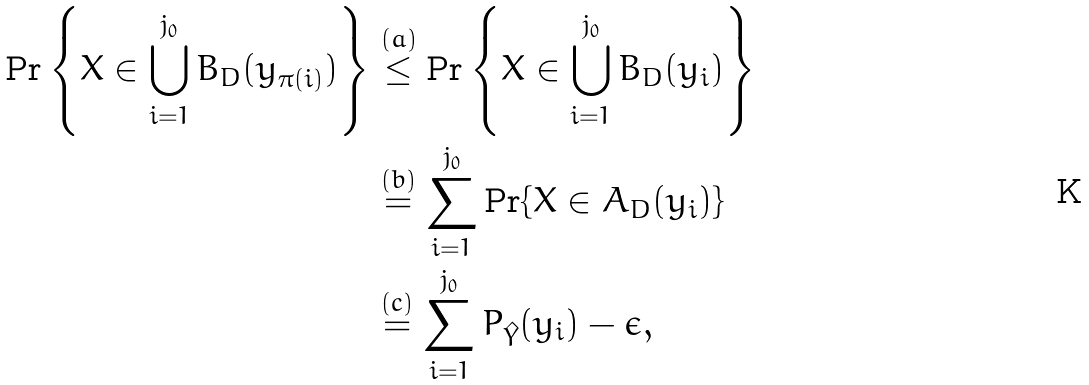Convert formula to latex. <formula><loc_0><loc_0><loc_500><loc_500>\Pr \left \{ X \in \bigcup _ { i = 1 } ^ { j _ { 0 } } B _ { D } ( y _ { \pi ( i ) } ) \right \} & \overset { ( a ) } { \leq } \Pr \left \{ X \in \bigcup _ { i = 1 } ^ { j _ { 0 } } B _ { D } ( y _ { i } ) \right \} \\ & \overset { ( b ) } { = } \sum ^ { j _ { 0 } } _ { i = 1 } \Pr \{ X \in A _ { D } ( y _ { i } ) \} \\ & \overset { ( c ) } { = } \sum ^ { j _ { 0 } } _ { i = 1 } P _ { \hat { Y } } ( y _ { i } ) - \epsilon ,</formula> 